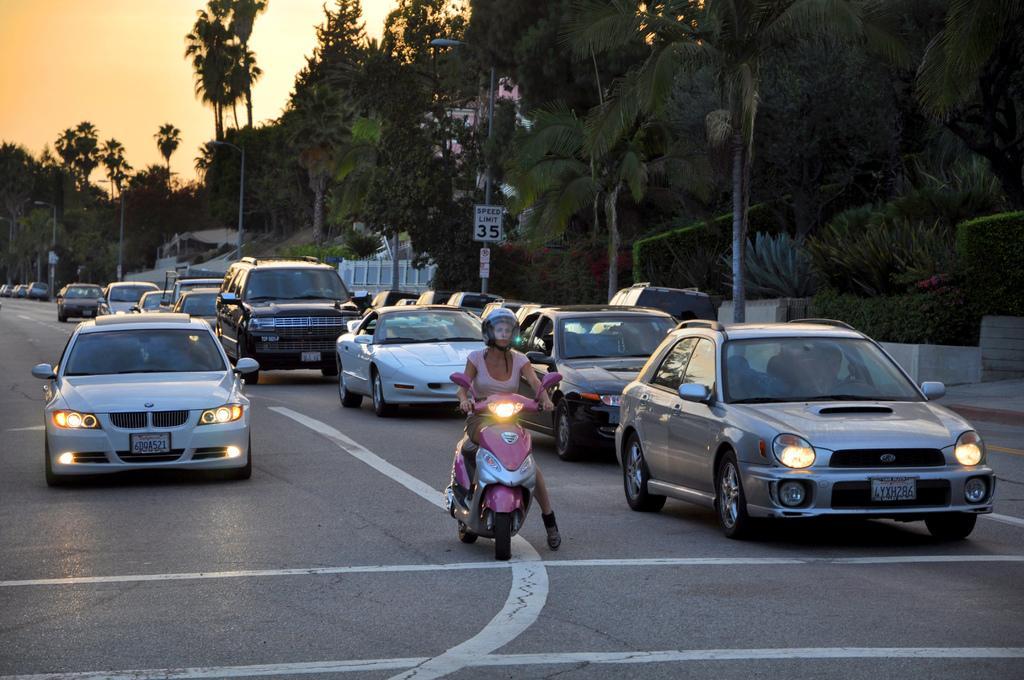Could you give a brief overview of what you see in this image? In this image I can see few vehicles on the road. I can see few trees, poles, boards, sky and the light poles. 